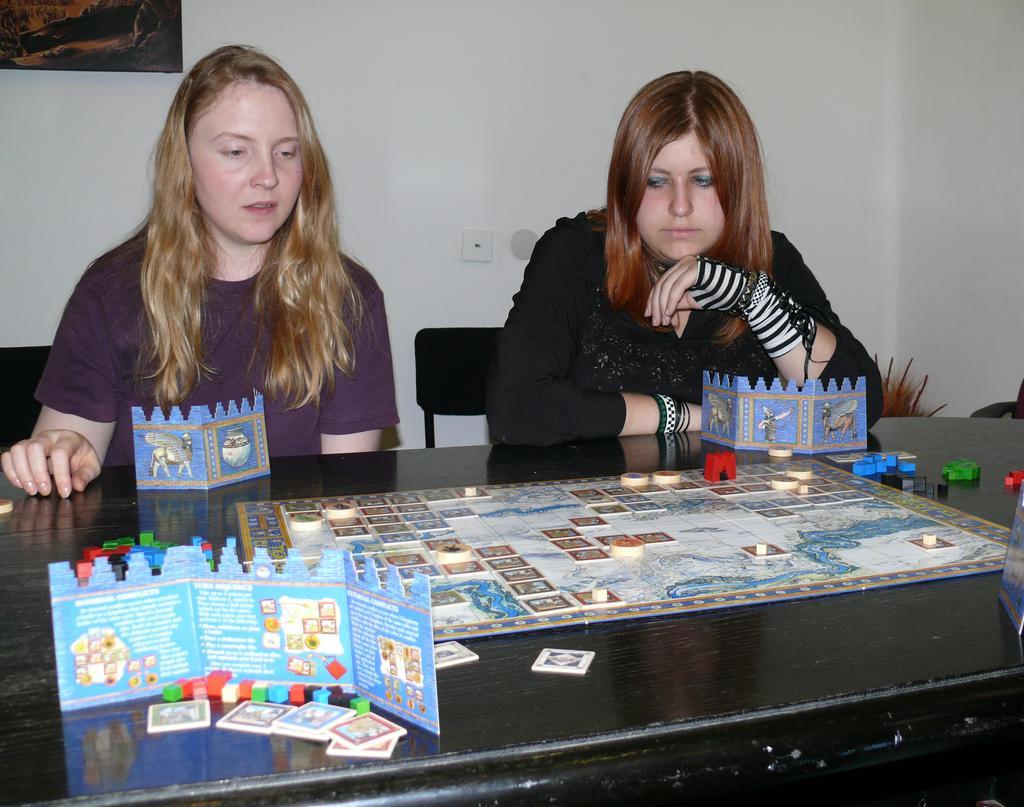Could you give a brief overview of what you see in this image? In a picture there are two women sitting on the chairs in front of the table. On the table there is a one matt with coins on it and there are cards and cubes present, the right corner of the picture the woman is wearing a black shirt and gloves behind her there is a big wall and in the left corner of the picture the girl is wearing purple shirt. 